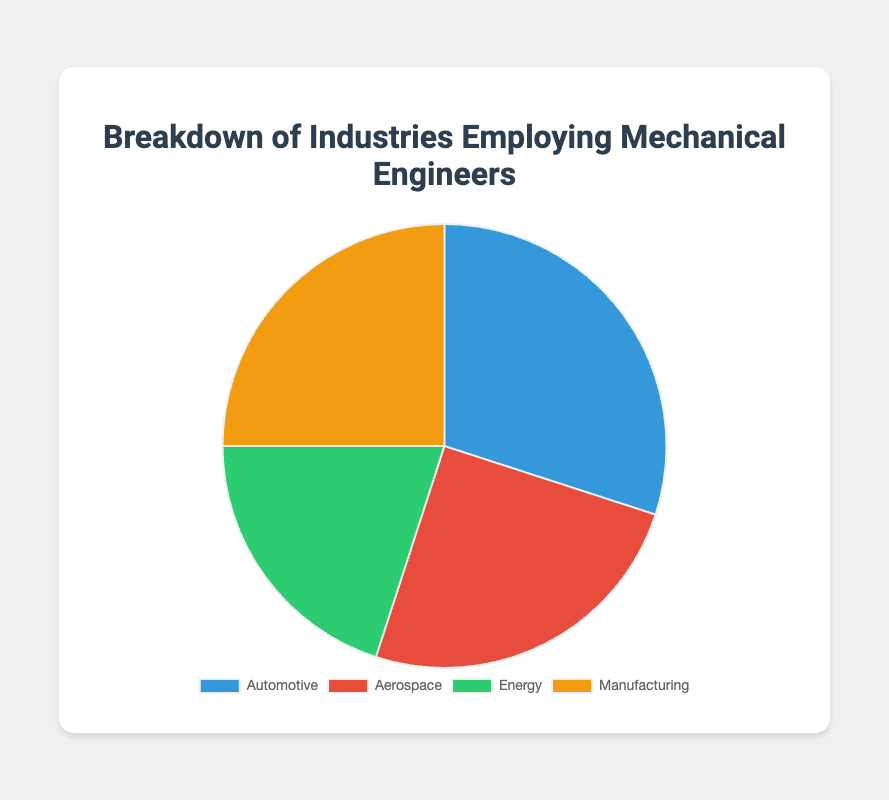What is the second largest industry employing mechanical engineers? The second largest industry is determined by finding the industry with the second highest percentage. The largest industry is “Automotive” with 30%, so the next largest are “Aerospace” and “Manufacturing” with 25% each.
Answer: Aerospace/Manufacturing Which industry employs fewer mechanical engineers, Energy or Aerospace? To determine which industry employs fewer mechanical engineers, compare their percentages. The “Energy” industry employs 20% while the “Aerospace” industry employs 25%. Hence, “Energy” employs fewer mechanical engineers.
Answer: Energy How much greater is the percentage of mechanical engineers employed in the Automotive industry compared to the Energy industry? Subtract the percentage of mechanical engineers employed in the Energy industry from the percentage employed in the Automotive industry: 30% - 20% = 10%.
Answer: 10% What's the combined percentage of mechanical engineers employed in Aerospace and Manufacturing industries? Sum the percentages of mechanical engineers employed in Aerospace and Manufacturing: 25% + 25% = 50%.
Answer: 50% What color represents the Energy industry in the pie chart? By observing the pie chart, the Energy industry slice is represented in green.
Answer: Green 